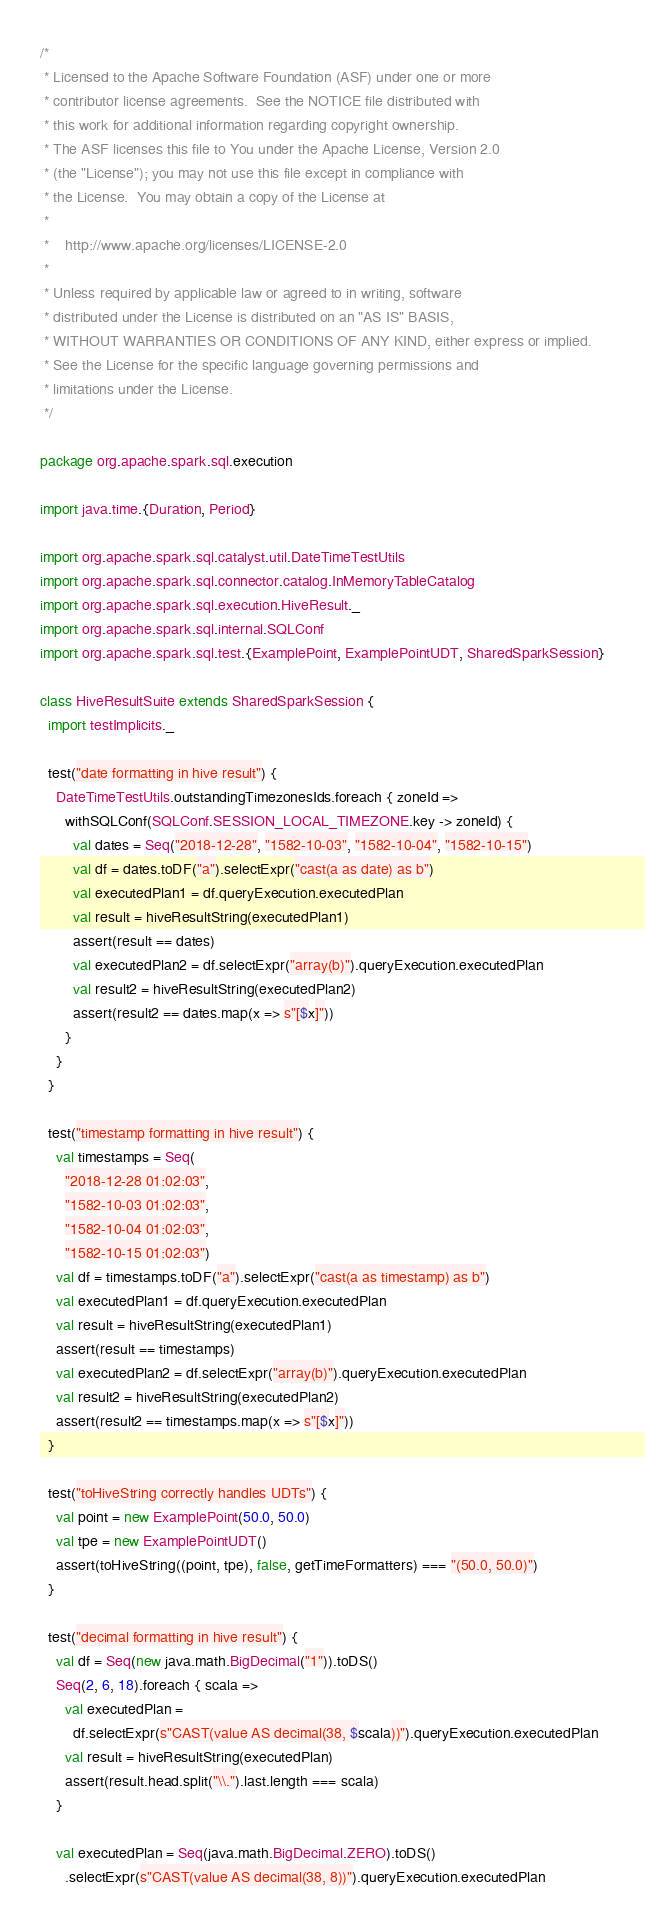Convert code to text. <code><loc_0><loc_0><loc_500><loc_500><_Scala_>/*
 * Licensed to the Apache Software Foundation (ASF) under one or more
 * contributor license agreements.  See the NOTICE file distributed with
 * this work for additional information regarding copyright ownership.
 * The ASF licenses this file to You under the Apache License, Version 2.0
 * (the "License"); you may not use this file except in compliance with
 * the License.  You may obtain a copy of the License at
 *
 *    http://www.apache.org/licenses/LICENSE-2.0
 *
 * Unless required by applicable law or agreed to in writing, software
 * distributed under the License is distributed on an "AS IS" BASIS,
 * WITHOUT WARRANTIES OR CONDITIONS OF ANY KIND, either express or implied.
 * See the License for the specific language governing permissions and
 * limitations under the License.
 */

package org.apache.spark.sql.execution

import java.time.{Duration, Period}

import org.apache.spark.sql.catalyst.util.DateTimeTestUtils
import org.apache.spark.sql.connector.catalog.InMemoryTableCatalog
import org.apache.spark.sql.execution.HiveResult._
import org.apache.spark.sql.internal.SQLConf
import org.apache.spark.sql.test.{ExamplePoint, ExamplePointUDT, SharedSparkSession}

class HiveResultSuite extends SharedSparkSession {
  import testImplicits._

  test("date formatting in hive result") {
    DateTimeTestUtils.outstandingTimezonesIds.foreach { zoneId =>
      withSQLConf(SQLConf.SESSION_LOCAL_TIMEZONE.key -> zoneId) {
        val dates = Seq("2018-12-28", "1582-10-03", "1582-10-04", "1582-10-15")
        val df = dates.toDF("a").selectExpr("cast(a as date) as b")
        val executedPlan1 = df.queryExecution.executedPlan
        val result = hiveResultString(executedPlan1)
        assert(result == dates)
        val executedPlan2 = df.selectExpr("array(b)").queryExecution.executedPlan
        val result2 = hiveResultString(executedPlan2)
        assert(result2 == dates.map(x => s"[$x]"))
      }
    }
  }

  test("timestamp formatting in hive result") {
    val timestamps = Seq(
      "2018-12-28 01:02:03",
      "1582-10-03 01:02:03",
      "1582-10-04 01:02:03",
      "1582-10-15 01:02:03")
    val df = timestamps.toDF("a").selectExpr("cast(a as timestamp) as b")
    val executedPlan1 = df.queryExecution.executedPlan
    val result = hiveResultString(executedPlan1)
    assert(result == timestamps)
    val executedPlan2 = df.selectExpr("array(b)").queryExecution.executedPlan
    val result2 = hiveResultString(executedPlan2)
    assert(result2 == timestamps.map(x => s"[$x]"))
  }

  test("toHiveString correctly handles UDTs") {
    val point = new ExamplePoint(50.0, 50.0)
    val tpe = new ExamplePointUDT()
    assert(toHiveString((point, tpe), false, getTimeFormatters) === "(50.0, 50.0)")
  }

  test("decimal formatting in hive result") {
    val df = Seq(new java.math.BigDecimal("1")).toDS()
    Seq(2, 6, 18).foreach { scala =>
      val executedPlan =
        df.selectExpr(s"CAST(value AS decimal(38, $scala))").queryExecution.executedPlan
      val result = hiveResultString(executedPlan)
      assert(result.head.split("\\.").last.length === scala)
    }

    val executedPlan = Seq(java.math.BigDecimal.ZERO).toDS()
      .selectExpr(s"CAST(value AS decimal(38, 8))").queryExecution.executedPlan</code> 